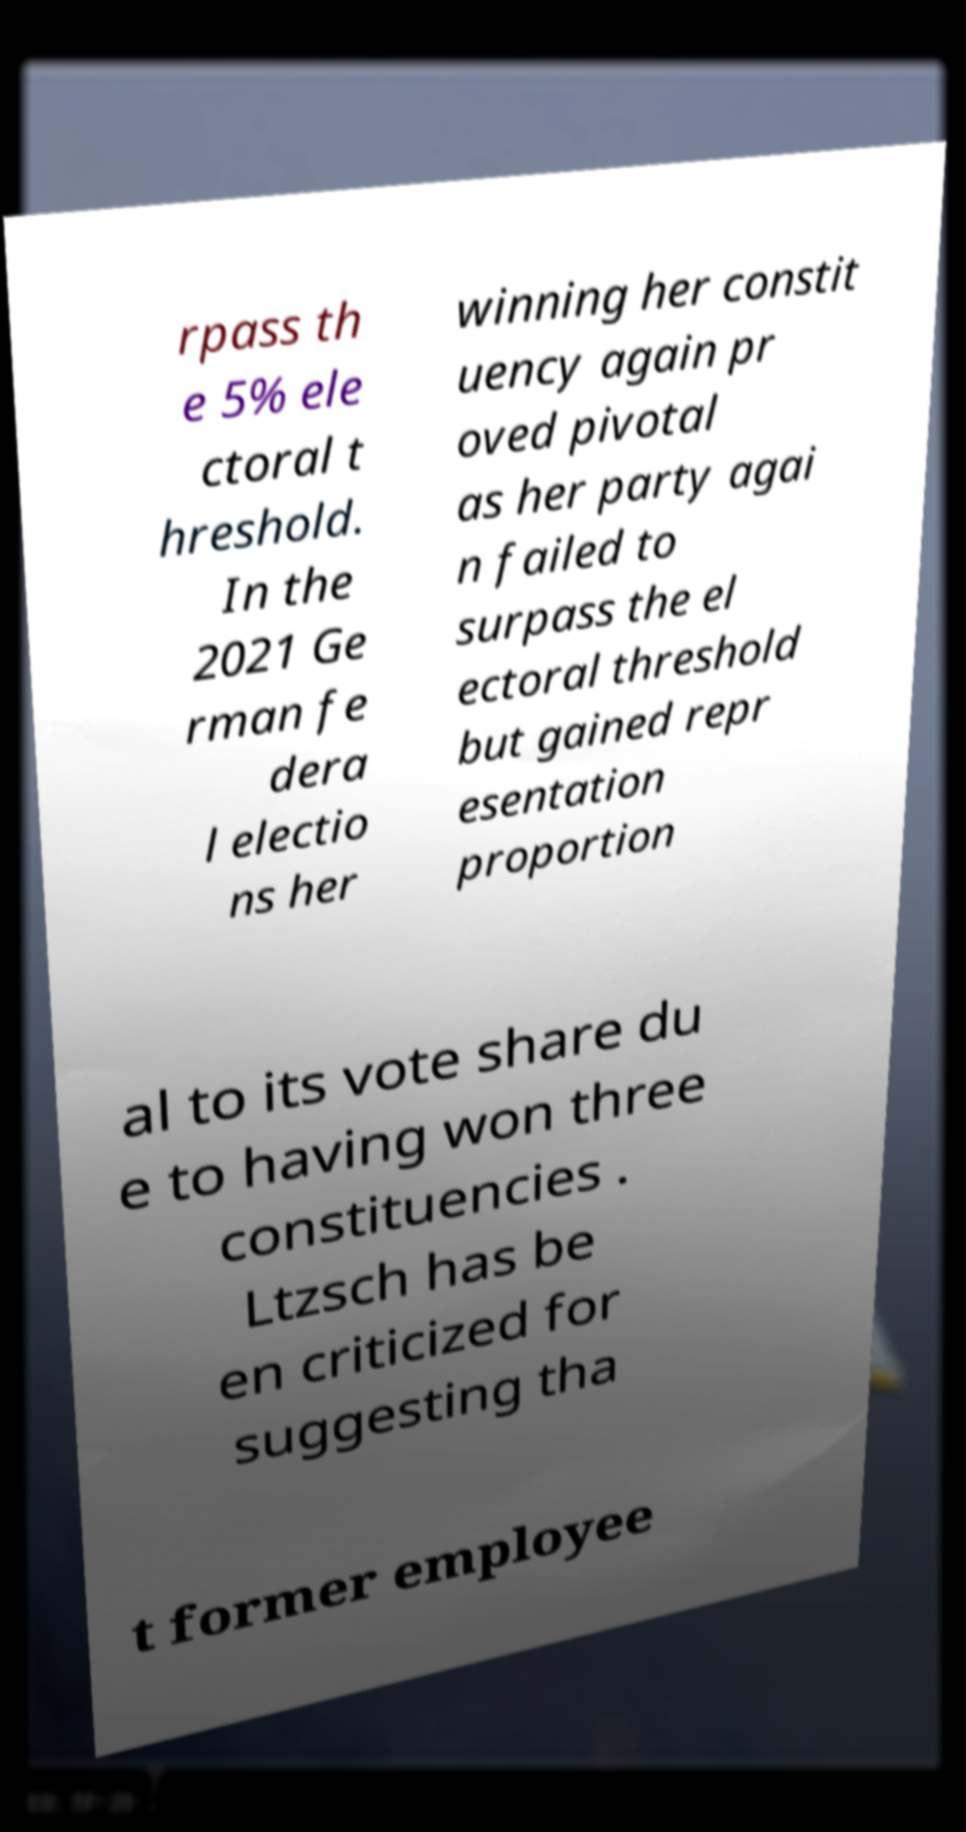What messages or text are displayed in this image? I need them in a readable, typed format. rpass th e 5% ele ctoral t hreshold. In the 2021 Ge rman fe dera l electio ns her winning her constit uency again pr oved pivotal as her party agai n failed to surpass the el ectoral threshold but gained repr esentation proportion al to its vote share du e to having won three constituencies . Ltzsch has be en criticized for suggesting tha t former employee 